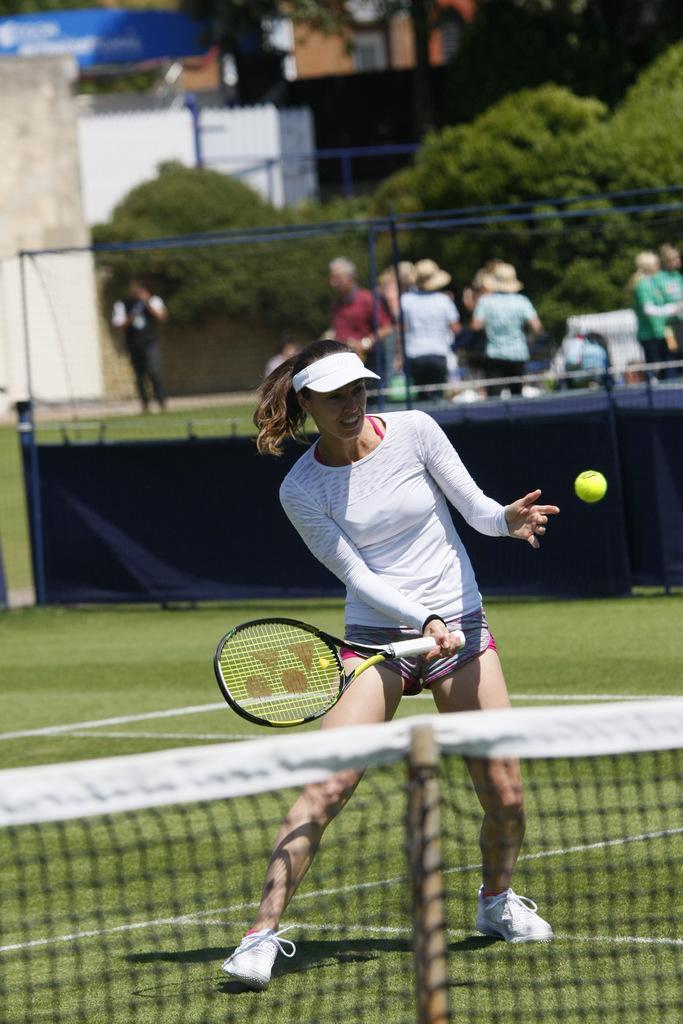How would you summarize this image in a sentence or two? In this image I can see a woman holding a racket in her hand. Here I can see a tennis ball. In the background I can see number of people and number of trees. 